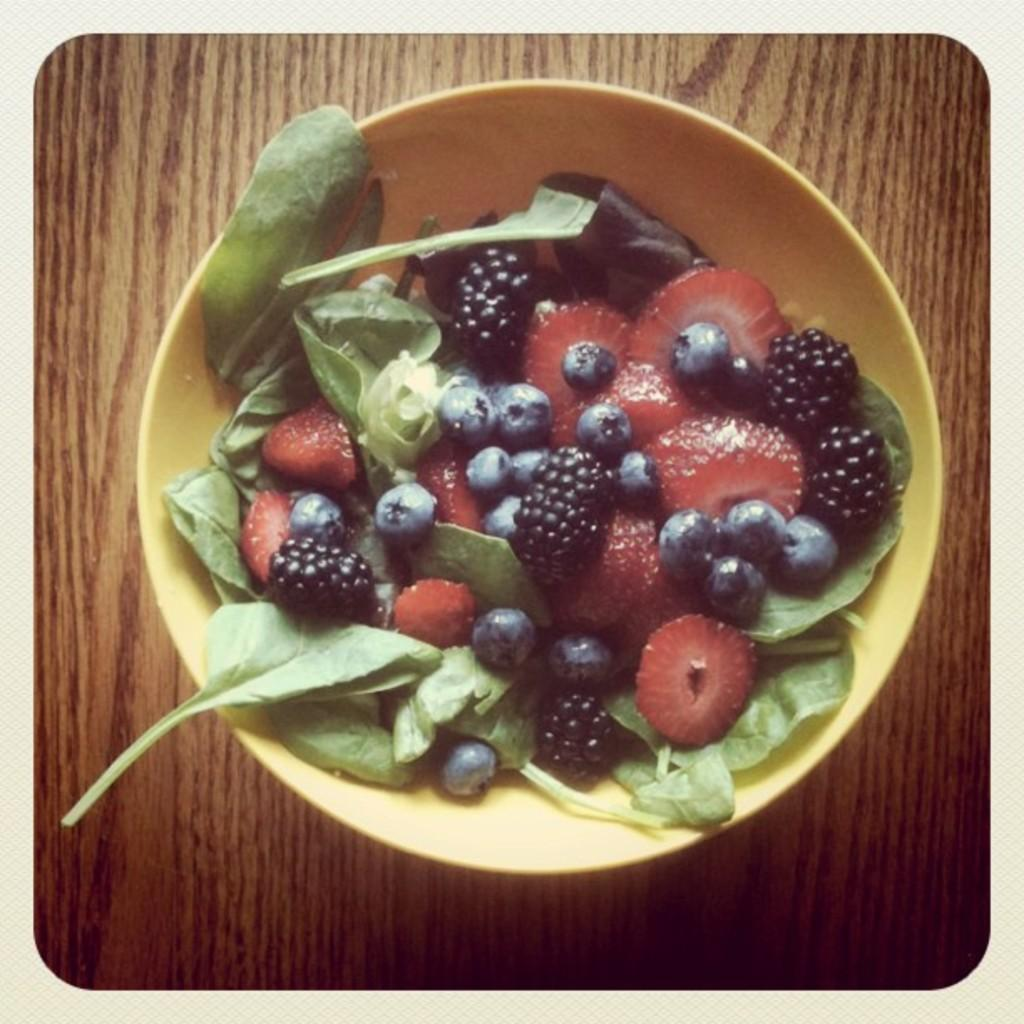What is on the table in the image? There is a bowl on the table in the image. What is inside the bowl? The bowl contains strawberries, blueberries, and green leaves. Can you describe the contents of the bowl in more detail? The bowl contains strawberries, blueberries, and green leaves, which might be salad ingredients or a fruit salad. What role does the actor play in the image? There is no actor present in the image; it features a bowl with strawberries, blueberries, and green leaves. 